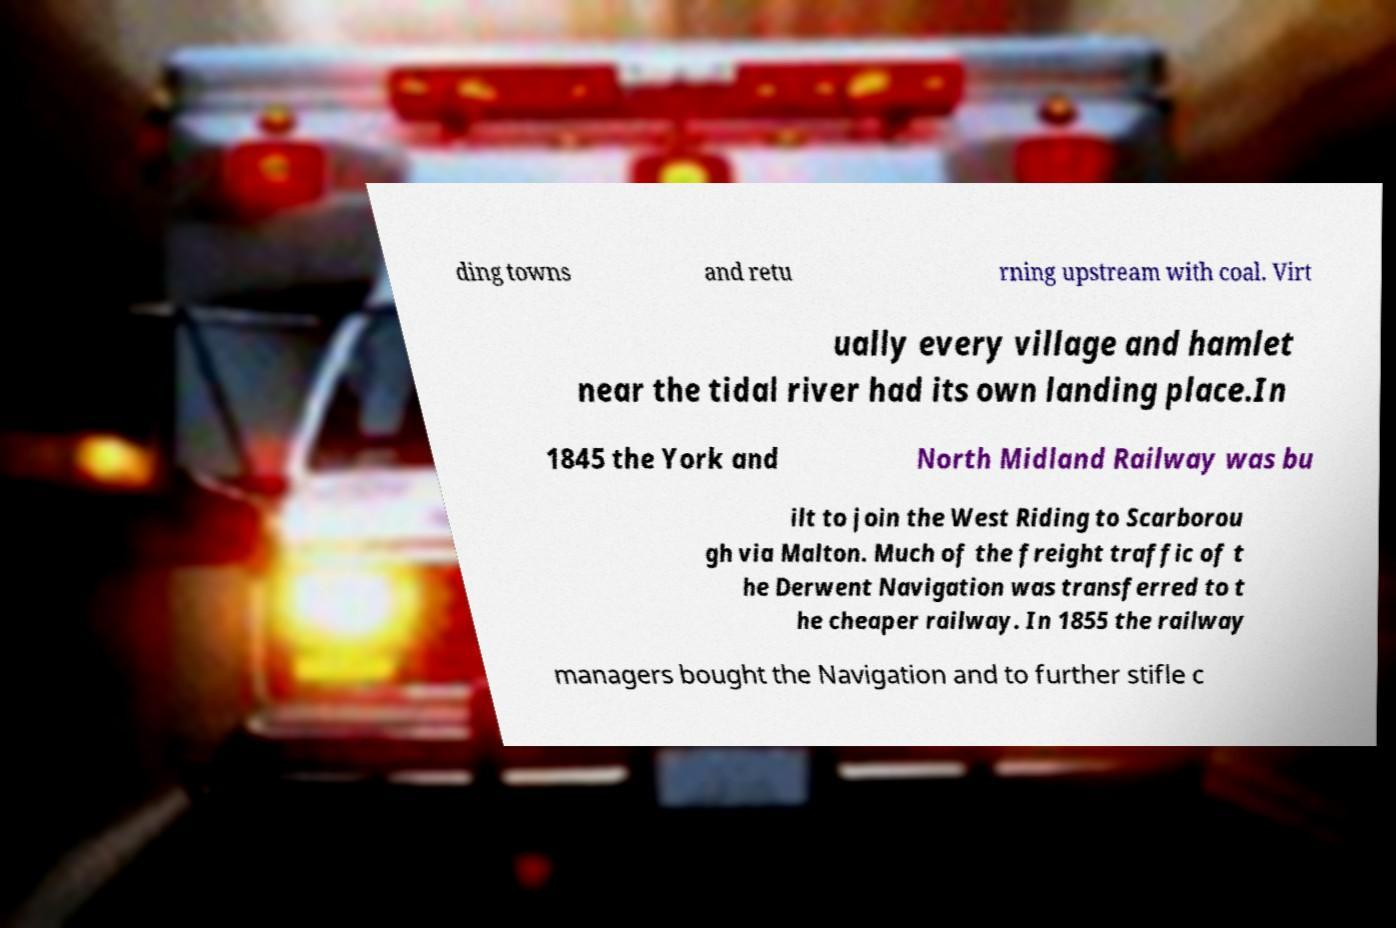Please identify and transcribe the text found in this image. ding towns and retu rning upstream with coal. Virt ually every village and hamlet near the tidal river had its own landing place.In 1845 the York and North Midland Railway was bu ilt to join the West Riding to Scarborou gh via Malton. Much of the freight traffic of t he Derwent Navigation was transferred to t he cheaper railway. In 1855 the railway managers bought the Navigation and to further stifle c 